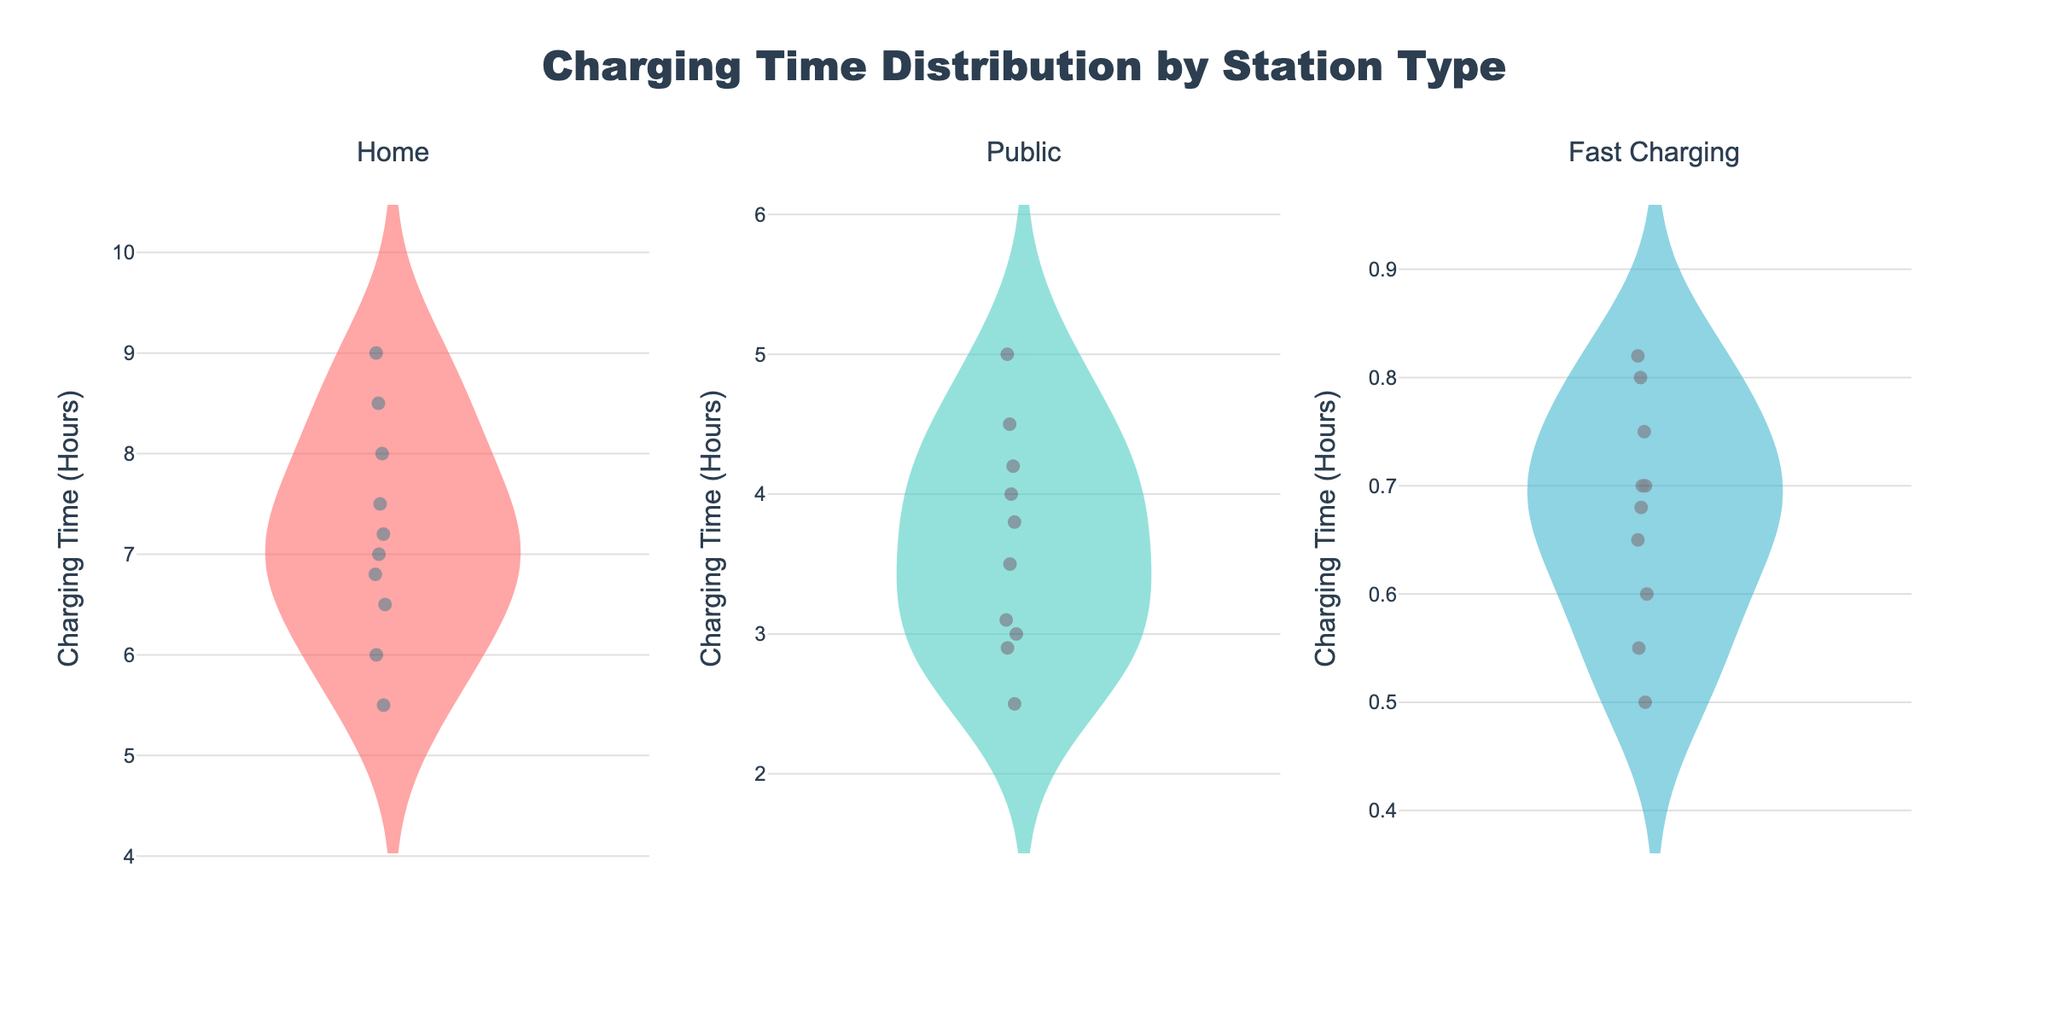What is the title of the figure? The title can be found at the top center of the figure.
Answer: Charging Time Distribution by Station Type How many different charging station types are presented in the figure? By counting the number of subplot titles, we can determine the number of types.
Answer: Three What is the range of charging times for Home charging stations? By looking at the spread of the data points and the ends of the violin plot for Home, we can identify the range.
Answer: 5.5 to 9 hours Which charging station type shows the narrowest range of charging times? Comparing the spread (width) of data points and the ends of the violin plots for each station type, we see that Fast Charging has the narrowest range.
Answer: Fast Charging What is the median charging time for Public charging stations? The median is indicated by the white dot within the violin plot for Public charging stations.
Answer: 3.5 hours Which charging station type has the highest average charging time? The average charging time is indicated by the mean line within the violin plot. The Home charging station has the highest average line.
Answer: Home Compare the spread of charging times for Home and Public charging stations. The spread is shown by the height of the violin plots. The Home charging station has a wider spread than the Public charging station.
Answer: Home has a wider spread What is the most frequent charging time for Fast Charging stations? The most frequent charging time is indicated by the widest part of the violin plot for Fast Charging stations.
Answer: 0.7 hours Is there any overlap in the charging times between Public and Fast Charging stations? By comparing the ranges of the violin plots for Public (2.5 to 5 hours) and Fast Charging (0.5 to 0.82 hours), we can see there is no overlap.
Answer: No 